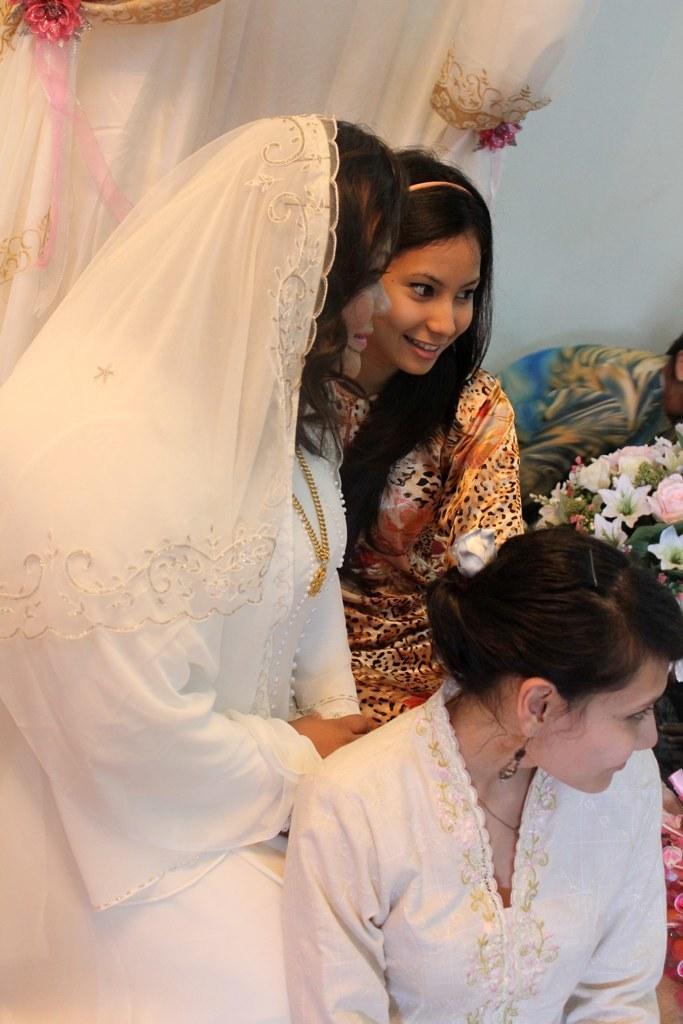Please provide a concise description of this image. In this image I can see three people are wearing different color dress. I can see flowers and white color curtain. The wall is in white color. 